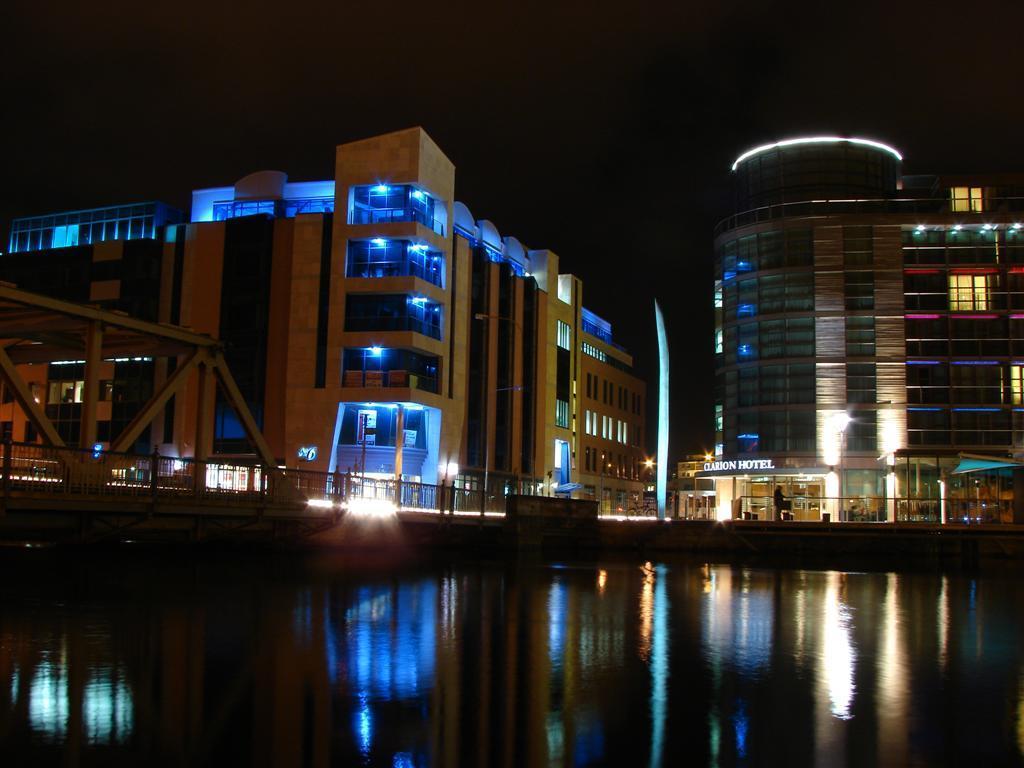In one or two sentences, can you explain what this image depicts? In this image there are few buildings, a bridge, fences and reflections of buildings in the water. 